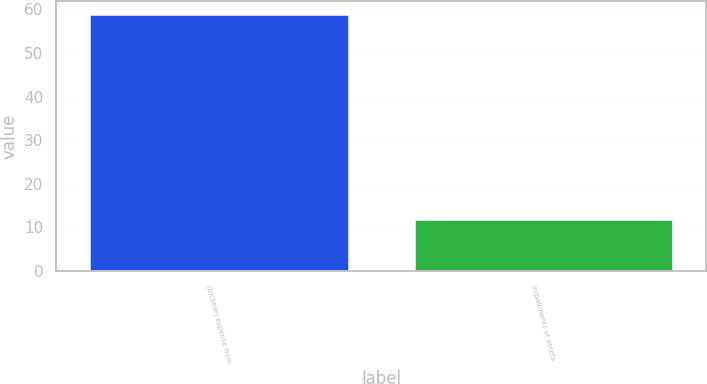<chart> <loc_0><loc_0><loc_500><loc_500><bar_chart><fcel>(Income) expense from<fcel>Impairments of assets<nl><fcel>59<fcel>12<nl></chart> 